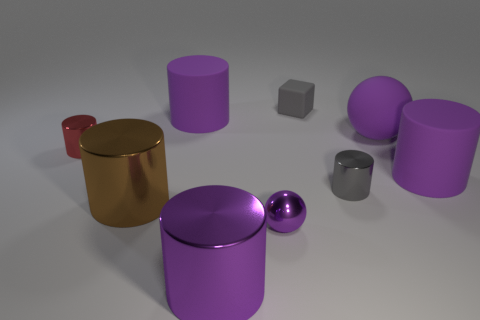What is the size of the red cylinder?
Ensure brevity in your answer.  Small. Is the number of tiny matte objects that are in front of the red metallic cylinder less than the number of purple rubber cylinders?
Give a very brief answer. Yes. Are the brown cylinder and the purple ball behind the small red metal cylinder made of the same material?
Make the answer very short. No. There is a large metallic cylinder that is left of the purple shiny object on the left side of the tiny purple sphere; are there any tiny balls that are on the left side of it?
Your answer should be very brief. No. Are there any other things that have the same size as the red cylinder?
Offer a very short reply. Yes. There is a ball that is made of the same material as the tiny gray cylinder; what is its color?
Ensure brevity in your answer.  Purple. There is a purple thing that is both in front of the tiny red metal cylinder and behind the tiny gray cylinder; how big is it?
Make the answer very short. Large. Are there fewer small purple metal balls behind the brown metallic thing than shiny things that are on the right side of the matte block?
Your response must be concise. Yes. Is the purple ball on the left side of the small rubber thing made of the same material as the purple object that is in front of the tiny metal sphere?
Make the answer very short. Yes. What material is the other sphere that is the same color as the metal ball?
Offer a very short reply. Rubber. 